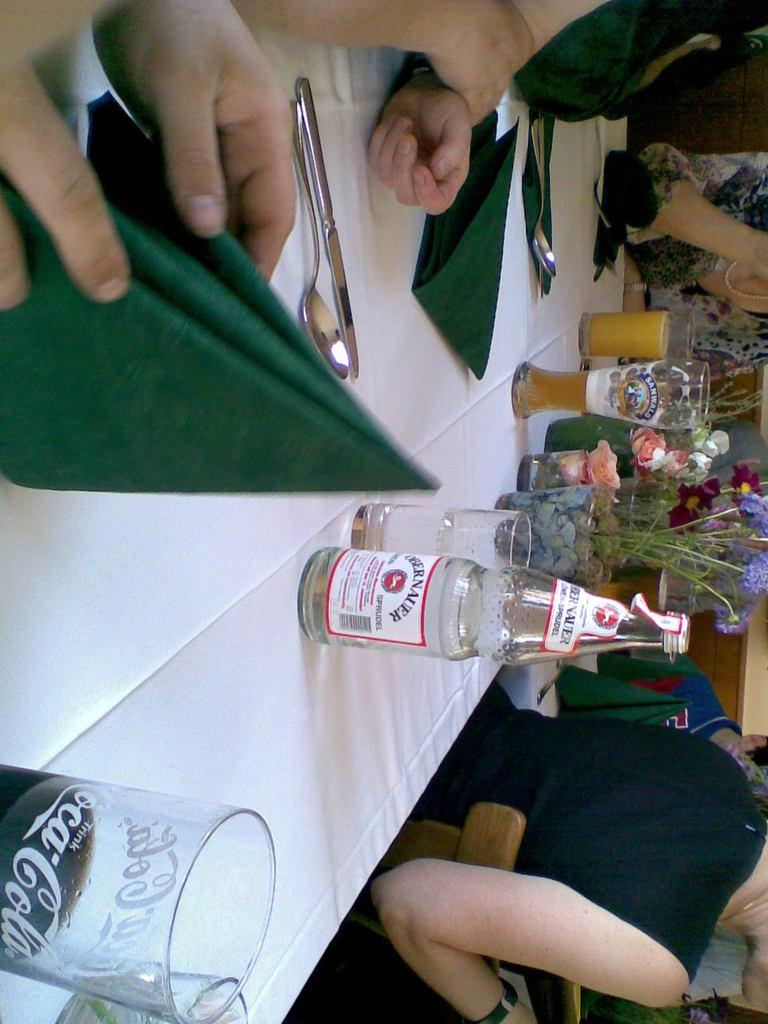What piece of furniture is present in the image? There is a table in the image. What items can be seen on the table? There are tissues, a spoon, a knife, a bottle, glasses, and a flower vase with flowers on the table. Are there any people near the table? Yes, there are people near the table. What type of knowledge is being shared among the people near the table? The image does not provide any information about the type of knowledge being shared among the people near the table. 